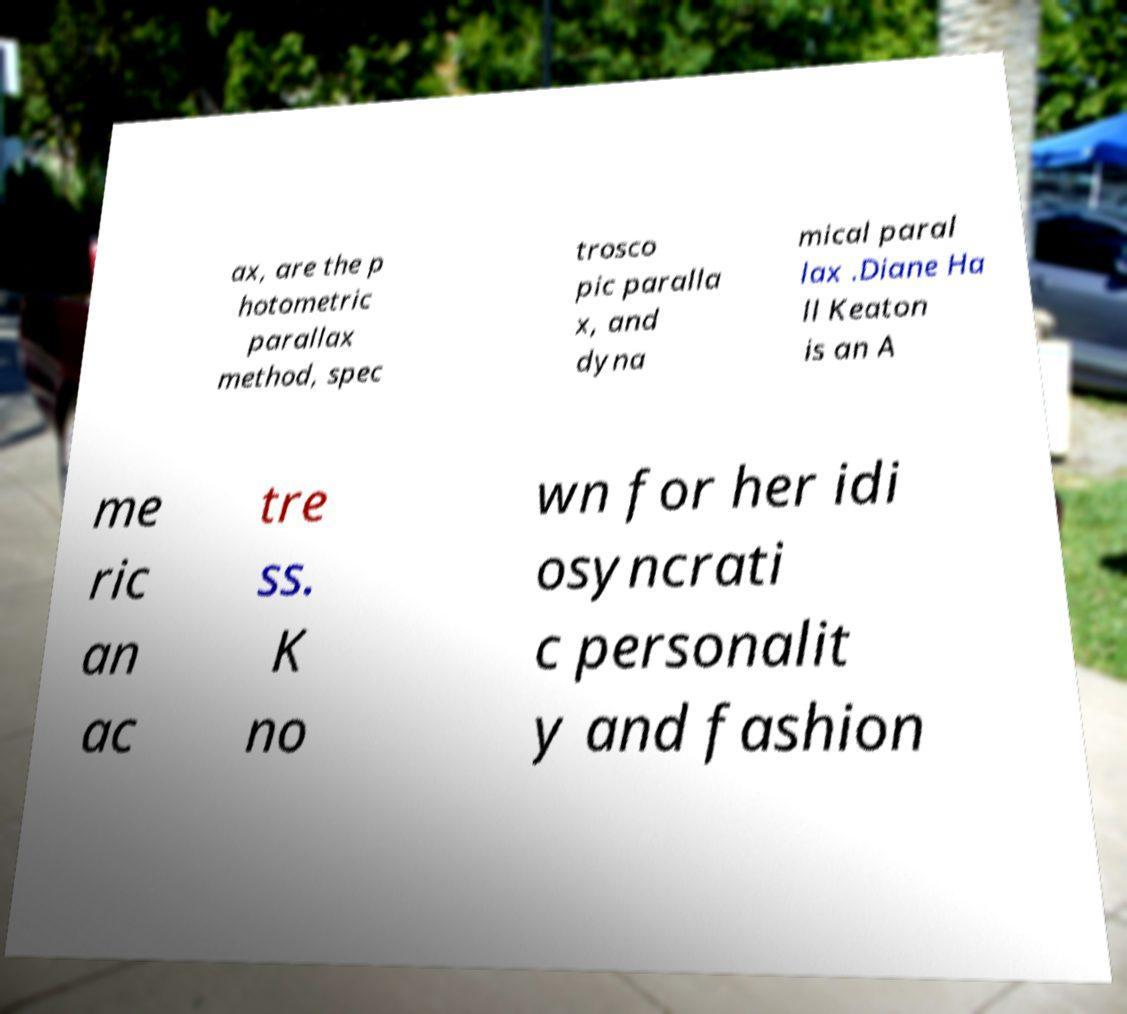Can you read and provide the text displayed in the image?This photo seems to have some interesting text. Can you extract and type it out for me? ax, are the p hotometric parallax method, spec trosco pic paralla x, and dyna mical paral lax .Diane Ha ll Keaton is an A me ric an ac tre ss. K no wn for her idi osyncrati c personalit y and fashion 